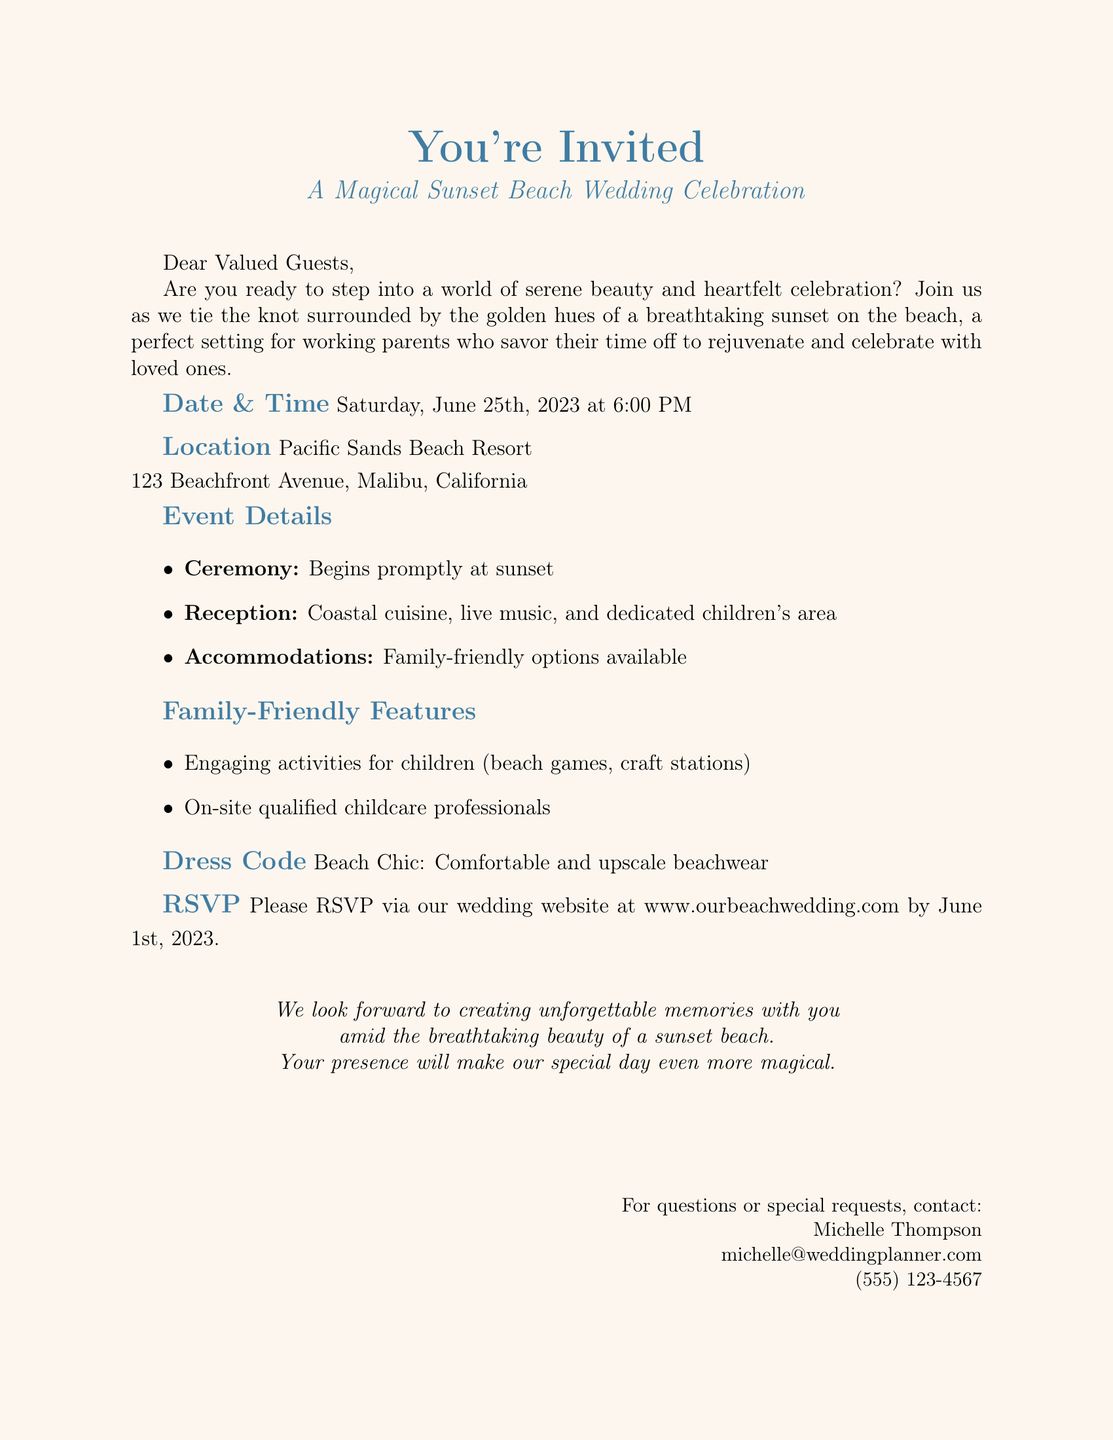What is the date of the wedding? The date of the wedding is clearly stated in the event details section of the document.
Answer: June 25th, 2023 What time does the ceremony start? The ceremony start time is specified directly after the date in the event details section.
Answer: 6:00 PM Where is the wedding location? The location of the wedding is mentioned in the location section of the document.
Answer: Pacific Sands Beach Resort What type of cuisine will be served at the reception? The type of cuisine is noted in the event details under reception details.
Answer: Coastal cuisine What activities are provided for children? Engaging activities for children are listed in the family-friendly features section of the document.
Answer: Beach games, craft stations What does "Beach Chic" refer to in the document? "Beach Chic" is mentioned under the dress code section as a guideline for attendees' attire.
Answer: Dress code By what date should guests RSVP? The RSVP deadline is stated towards the end of the invitation, explicitly mentioning the date.
Answer: June 1st, 2023 Who should be contacted for questions or special requests? Contact information is listed at the bottom of the invitation, indicating the person to reach out to.
Answer: Michelle Thompson What kind of professionals will be available for childcare? The type of professionals available for childcare is detailed in the family-friendly features section.
Answer: Qualified childcare professionals 